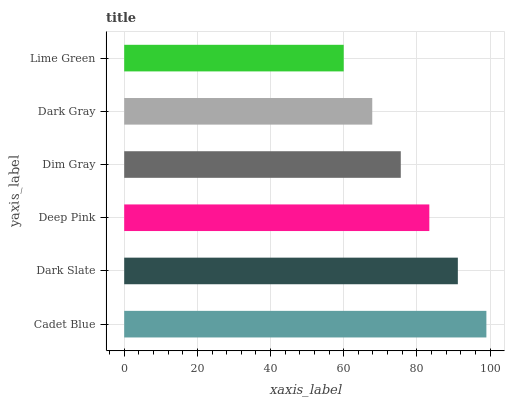Is Lime Green the minimum?
Answer yes or no. Yes. Is Cadet Blue the maximum?
Answer yes or no. Yes. Is Dark Slate the minimum?
Answer yes or no. No. Is Dark Slate the maximum?
Answer yes or no. No. Is Cadet Blue greater than Dark Slate?
Answer yes or no. Yes. Is Dark Slate less than Cadet Blue?
Answer yes or no. Yes. Is Dark Slate greater than Cadet Blue?
Answer yes or no. No. Is Cadet Blue less than Dark Slate?
Answer yes or no. No. Is Deep Pink the high median?
Answer yes or no. Yes. Is Dim Gray the low median?
Answer yes or no. Yes. Is Dark Gray the high median?
Answer yes or no. No. Is Deep Pink the low median?
Answer yes or no. No. 